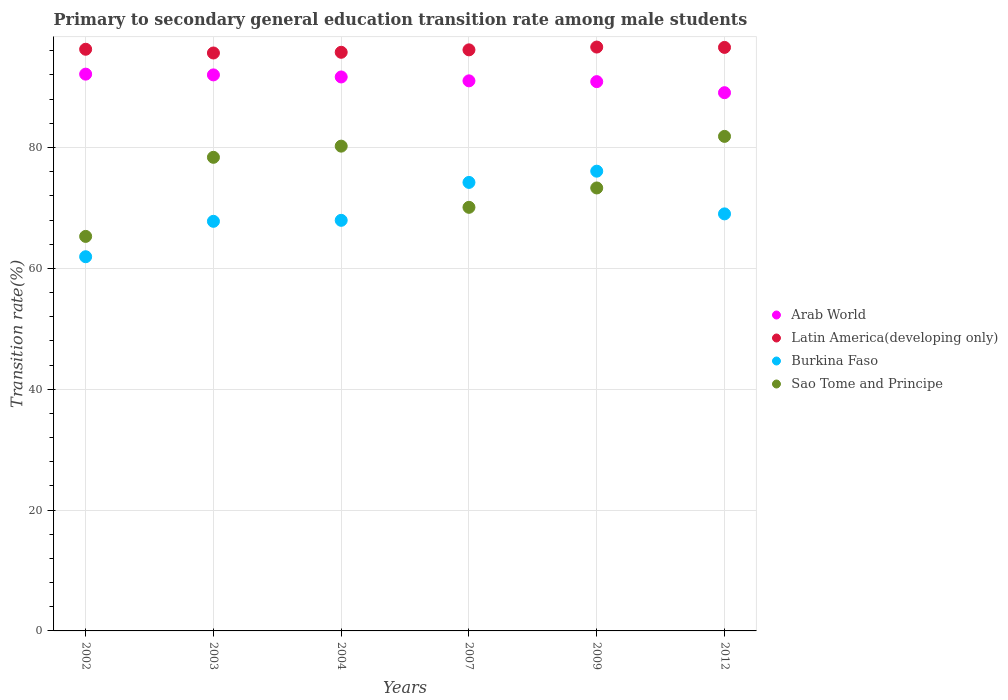How many different coloured dotlines are there?
Provide a succinct answer. 4. What is the transition rate in Burkina Faso in 2003?
Offer a terse response. 67.78. Across all years, what is the maximum transition rate in Sao Tome and Principe?
Offer a very short reply. 81.84. Across all years, what is the minimum transition rate in Arab World?
Your answer should be compact. 89.07. In which year was the transition rate in Arab World maximum?
Offer a terse response. 2002. What is the total transition rate in Arab World in the graph?
Your answer should be very brief. 546.83. What is the difference between the transition rate in Sao Tome and Principe in 2004 and that in 2012?
Offer a terse response. -1.62. What is the difference between the transition rate in Arab World in 2002 and the transition rate in Latin America(developing only) in 2009?
Provide a short and direct response. -4.48. What is the average transition rate in Sao Tome and Principe per year?
Provide a succinct answer. 74.86. In the year 2003, what is the difference between the transition rate in Latin America(developing only) and transition rate in Arab World?
Your answer should be very brief. 3.62. In how many years, is the transition rate in Burkina Faso greater than 84 %?
Provide a short and direct response. 0. What is the ratio of the transition rate in Latin America(developing only) in 2007 to that in 2009?
Ensure brevity in your answer.  1. Is the transition rate in Latin America(developing only) in 2009 less than that in 2012?
Offer a terse response. No. What is the difference between the highest and the second highest transition rate in Latin America(developing only)?
Provide a short and direct response. 0.06. What is the difference between the highest and the lowest transition rate in Latin America(developing only)?
Make the answer very short. 0.98. Does the graph contain grids?
Provide a short and direct response. Yes. Where does the legend appear in the graph?
Provide a succinct answer. Center right. How many legend labels are there?
Ensure brevity in your answer.  4. What is the title of the graph?
Give a very brief answer. Primary to secondary general education transition rate among male students. Does "Colombia" appear as one of the legend labels in the graph?
Provide a succinct answer. No. What is the label or title of the X-axis?
Provide a succinct answer. Years. What is the label or title of the Y-axis?
Provide a succinct answer. Transition rate(%). What is the Transition rate(%) of Arab World in 2002?
Provide a short and direct response. 92.14. What is the Transition rate(%) of Latin America(developing only) in 2002?
Ensure brevity in your answer.  96.26. What is the Transition rate(%) of Burkina Faso in 2002?
Ensure brevity in your answer.  61.93. What is the Transition rate(%) of Sao Tome and Principe in 2002?
Make the answer very short. 65.29. What is the Transition rate(%) of Arab World in 2003?
Provide a succinct answer. 92.02. What is the Transition rate(%) of Latin America(developing only) in 2003?
Offer a terse response. 95.64. What is the Transition rate(%) of Burkina Faso in 2003?
Provide a succinct answer. 67.78. What is the Transition rate(%) of Sao Tome and Principe in 2003?
Make the answer very short. 78.38. What is the Transition rate(%) of Arab World in 2004?
Provide a short and direct response. 91.67. What is the Transition rate(%) in Latin America(developing only) in 2004?
Make the answer very short. 95.76. What is the Transition rate(%) in Burkina Faso in 2004?
Provide a short and direct response. 67.95. What is the Transition rate(%) of Sao Tome and Principe in 2004?
Offer a very short reply. 80.23. What is the Transition rate(%) of Arab World in 2007?
Give a very brief answer. 91.03. What is the Transition rate(%) of Latin America(developing only) in 2007?
Provide a short and direct response. 96.16. What is the Transition rate(%) of Burkina Faso in 2007?
Make the answer very short. 74.22. What is the Transition rate(%) of Sao Tome and Principe in 2007?
Keep it short and to the point. 70.1. What is the Transition rate(%) in Arab World in 2009?
Give a very brief answer. 90.9. What is the Transition rate(%) in Latin America(developing only) in 2009?
Provide a short and direct response. 96.62. What is the Transition rate(%) of Burkina Faso in 2009?
Keep it short and to the point. 76.08. What is the Transition rate(%) in Sao Tome and Principe in 2009?
Keep it short and to the point. 73.3. What is the Transition rate(%) of Arab World in 2012?
Make the answer very short. 89.07. What is the Transition rate(%) in Latin America(developing only) in 2012?
Your answer should be compact. 96.56. What is the Transition rate(%) of Burkina Faso in 2012?
Give a very brief answer. 69.02. What is the Transition rate(%) in Sao Tome and Principe in 2012?
Make the answer very short. 81.84. Across all years, what is the maximum Transition rate(%) in Arab World?
Provide a short and direct response. 92.14. Across all years, what is the maximum Transition rate(%) of Latin America(developing only)?
Provide a succinct answer. 96.62. Across all years, what is the maximum Transition rate(%) in Burkina Faso?
Offer a terse response. 76.08. Across all years, what is the maximum Transition rate(%) of Sao Tome and Principe?
Your response must be concise. 81.84. Across all years, what is the minimum Transition rate(%) in Arab World?
Offer a terse response. 89.07. Across all years, what is the minimum Transition rate(%) of Latin America(developing only)?
Keep it short and to the point. 95.64. Across all years, what is the minimum Transition rate(%) in Burkina Faso?
Your answer should be compact. 61.93. Across all years, what is the minimum Transition rate(%) of Sao Tome and Principe?
Your answer should be very brief. 65.29. What is the total Transition rate(%) in Arab World in the graph?
Offer a very short reply. 546.83. What is the total Transition rate(%) of Latin America(developing only) in the graph?
Your response must be concise. 577.01. What is the total Transition rate(%) in Burkina Faso in the graph?
Keep it short and to the point. 416.98. What is the total Transition rate(%) in Sao Tome and Principe in the graph?
Offer a terse response. 449.14. What is the difference between the Transition rate(%) of Arab World in 2002 and that in 2003?
Your answer should be compact. 0.12. What is the difference between the Transition rate(%) in Latin America(developing only) in 2002 and that in 2003?
Keep it short and to the point. 0.62. What is the difference between the Transition rate(%) of Burkina Faso in 2002 and that in 2003?
Give a very brief answer. -5.86. What is the difference between the Transition rate(%) of Sao Tome and Principe in 2002 and that in 2003?
Keep it short and to the point. -13.09. What is the difference between the Transition rate(%) of Arab World in 2002 and that in 2004?
Provide a short and direct response. 0.47. What is the difference between the Transition rate(%) in Latin America(developing only) in 2002 and that in 2004?
Keep it short and to the point. 0.5. What is the difference between the Transition rate(%) of Burkina Faso in 2002 and that in 2004?
Ensure brevity in your answer.  -6.02. What is the difference between the Transition rate(%) in Sao Tome and Principe in 2002 and that in 2004?
Your answer should be compact. -14.94. What is the difference between the Transition rate(%) of Arab World in 2002 and that in 2007?
Your answer should be very brief. 1.11. What is the difference between the Transition rate(%) in Latin America(developing only) in 2002 and that in 2007?
Provide a succinct answer. 0.1. What is the difference between the Transition rate(%) in Burkina Faso in 2002 and that in 2007?
Offer a terse response. -12.3. What is the difference between the Transition rate(%) of Sao Tome and Principe in 2002 and that in 2007?
Ensure brevity in your answer.  -4.81. What is the difference between the Transition rate(%) in Arab World in 2002 and that in 2009?
Give a very brief answer. 1.24. What is the difference between the Transition rate(%) in Latin America(developing only) in 2002 and that in 2009?
Offer a very short reply. -0.36. What is the difference between the Transition rate(%) in Burkina Faso in 2002 and that in 2009?
Ensure brevity in your answer.  -14.16. What is the difference between the Transition rate(%) in Sao Tome and Principe in 2002 and that in 2009?
Your response must be concise. -8.02. What is the difference between the Transition rate(%) of Arab World in 2002 and that in 2012?
Ensure brevity in your answer.  3.07. What is the difference between the Transition rate(%) in Latin America(developing only) in 2002 and that in 2012?
Your answer should be compact. -0.31. What is the difference between the Transition rate(%) of Burkina Faso in 2002 and that in 2012?
Your answer should be compact. -7.09. What is the difference between the Transition rate(%) in Sao Tome and Principe in 2002 and that in 2012?
Your answer should be compact. -16.55. What is the difference between the Transition rate(%) of Arab World in 2003 and that in 2004?
Offer a terse response. 0.34. What is the difference between the Transition rate(%) of Latin America(developing only) in 2003 and that in 2004?
Your answer should be very brief. -0.12. What is the difference between the Transition rate(%) of Burkina Faso in 2003 and that in 2004?
Offer a terse response. -0.16. What is the difference between the Transition rate(%) in Sao Tome and Principe in 2003 and that in 2004?
Offer a terse response. -1.85. What is the difference between the Transition rate(%) of Arab World in 2003 and that in 2007?
Your answer should be compact. 0.99. What is the difference between the Transition rate(%) of Latin America(developing only) in 2003 and that in 2007?
Make the answer very short. -0.52. What is the difference between the Transition rate(%) of Burkina Faso in 2003 and that in 2007?
Offer a terse response. -6.44. What is the difference between the Transition rate(%) of Sao Tome and Principe in 2003 and that in 2007?
Your answer should be very brief. 8.28. What is the difference between the Transition rate(%) in Arab World in 2003 and that in 2009?
Provide a short and direct response. 1.12. What is the difference between the Transition rate(%) in Latin America(developing only) in 2003 and that in 2009?
Your response must be concise. -0.98. What is the difference between the Transition rate(%) in Burkina Faso in 2003 and that in 2009?
Your response must be concise. -8.3. What is the difference between the Transition rate(%) of Sao Tome and Principe in 2003 and that in 2009?
Keep it short and to the point. 5.07. What is the difference between the Transition rate(%) of Arab World in 2003 and that in 2012?
Your answer should be very brief. 2.95. What is the difference between the Transition rate(%) of Latin America(developing only) in 2003 and that in 2012?
Your answer should be very brief. -0.92. What is the difference between the Transition rate(%) of Burkina Faso in 2003 and that in 2012?
Give a very brief answer. -1.23. What is the difference between the Transition rate(%) in Sao Tome and Principe in 2003 and that in 2012?
Keep it short and to the point. -3.46. What is the difference between the Transition rate(%) of Arab World in 2004 and that in 2007?
Provide a short and direct response. 0.64. What is the difference between the Transition rate(%) in Latin America(developing only) in 2004 and that in 2007?
Give a very brief answer. -0.4. What is the difference between the Transition rate(%) of Burkina Faso in 2004 and that in 2007?
Provide a short and direct response. -6.27. What is the difference between the Transition rate(%) of Sao Tome and Principe in 2004 and that in 2007?
Keep it short and to the point. 10.13. What is the difference between the Transition rate(%) of Arab World in 2004 and that in 2009?
Give a very brief answer. 0.77. What is the difference between the Transition rate(%) of Latin America(developing only) in 2004 and that in 2009?
Offer a very short reply. -0.87. What is the difference between the Transition rate(%) of Burkina Faso in 2004 and that in 2009?
Provide a short and direct response. -8.13. What is the difference between the Transition rate(%) of Sao Tome and Principe in 2004 and that in 2009?
Make the answer very short. 6.92. What is the difference between the Transition rate(%) in Arab World in 2004 and that in 2012?
Offer a terse response. 2.6. What is the difference between the Transition rate(%) in Latin America(developing only) in 2004 and that in 2012?
Make the answer very short. -0.81. What is the difference between the Transition rate(%) of Burkina Faso in 2004 and that in 2012?
Ensure brevity in your answer.  -1.07. What is the difference between the Transition rate(%) of Sao Tome and Principe in 2004 and that in 2012?
Offer a very short reply. -1.62. What is the difference between the Transition rate(%) of Arab World in 2007 and that in 2009?
Make the answer very short. 0.13. What is the difference between the Transition rate(%) of Latin America(developing only) in 2007 and that in 2009?
Offer a terse response. -0.46. What is the difference between the Transition rate(%) in Burkina Faso in 2007 and that in 2009?
Your answer should be compact. -1.86. What is the difference between the Transition rate(%) in Sao Tome and Principe in 2007 and that in 2009?
Provide a succinct answer. -3.2. What is the difference between the Transition rate(%) in Arab World in 2007 and that in 2012?
Offer a very short reply. 1.96. What is the difference between the Transition rate(%) in Latin America(developing only) in 2007 and that in 2012?
Offer a very short reply. -0.4. What is the difference between the Transition rate(%) in Burkina Faso in 2007 and that in 2012?
Your answer should be very brief. 5.21. What is the difference between the Transition rate(%) in Sao Tome and Principe in 2007 and that in 2012?
Provide a short and direct response. -11.74. What is the difference between the Transition rate(%) in Arab World in 2009 and that in 2012?
Your response must be concise. 1.83. What is the difference between the Transition rate(%) in Latin America(developing only) in 2009 and that in 2012?
Offer a very short reply. 0.06. What is the difference between the Transition rate(%) of Burkina Faso in 2009 and that in 2012?
Your answer should be compact. 7.07. What is the difference between the Transition rate(%) in Sao Tome and Principe in 2009 and that in 2012?
Your answer should be compact. -8.54. What is the difference between the Transition rate(%) of Arab World in 2002 and the Transition rate(%) of Latin America(developing only) in 2003?
Your answer should be compact. -3.5. What is the difference between the Transition rate(%) of Arab World in 2002 and the Transition rate(%) of Burkina Faso in 2003?
Keep it short and to the point. 24.36. What is the difference between the Transition rate(%) of Arab World in 2002 and the Transition rate(%) of Sao Tome and Principe in 2003?
Your answer should be very brief. 13.76. What is the difference between the Transition rate(%) of Latin America(developing only) in 2002 and the Transition rate(%) of Burkina Faso in 2003?
Your response must be concise. 28.48. What is the difference between the Transition rate(%) in Latin America(developing only) in 2002 and the Transition rate(%) in Sao Tome and Principe in 2003?
Keep it short and to the point. 17.88. What is the difference between the Transition rate(%) in Burkina Faso in 2002 and the Transition rate(%) in Sao Tome and Principe in 2003?
Your answer should be very brief. -16.45. What is the difference between the Transition rate(%) in Arab World in 2002 and the Transition rate(%) in Latin America(developing only) in 2004?
Offer a very short reply. -3.62. What is the difference between the Transition rate(%) of Arab World in 2002 and the Transition rate(%) of Burkina Faso in 2004?
Your answer should be compact. 24.19. What is the difference between the Transition rate(%) in Arab World in 2002 and the Transition rate(%) in Sao Tome and Principe in 2004?
Ensure brevity in your answer.  11.91. What is the difference between the Transition rate(%) of Latin America(developing only) in 2002 and the Transition rate(%) of Burkina Faso in 2004?
Offer a very short reply. 28.31. What is the difference between the Transition rate(%) of Latin America(developing only) in 2002 and the Transition rate(%) of Sao Tome and Principe in 2004?
Your answer should be very brief. 16.03. What is the difference between the Transition rate(%) in Burkina Faso in 2002 and the Transition rate(%) in Sao Tome and Principe in 2004?
Keep it short and to the point. -18.3. What is the difference between the Transition rate(%) of Arab World in 2002 and the Transition rate(%) of Latin America(developing only) in 2007?
Keep it short and to the point. -4.02. What is the difference between the Transition rate(%) in Arab World in 2002 and the Transition rate(%) in Burkina Faso in 2007?
Offer a very short reply. 17.92. What is the difference between the Transition rate(%) in Arab World in 2002 and the Transition rate(%) in Sao Tome and Principe in 2007?
Your answer should be compact. 22.04. What is the difference between the Transition rate(%) in Latin America(developing only) in 2002 and the Transition rate(%) in Burkina Faso in 2007?
Your response must be concise. 22.04. What is the difference between the Transition rate(%) in Latin America(developing only) in 2002 and the Transition rate(%) in Sao Tome and Principe in 2007?
Ensure brevity in your answer.  26.16. What is the difference between the Transition rate(%) of Burkina Faso in 2002 and the Transition rate(%) of Sao Tome and Principe in 2007?
Offer a very short reply. -8.17. What is the difference between the Transition rate(%) in Arab World in 2002 and the Transition rate(%) in Latin America(developing only) in 2009?
Give a very brief answer. -4.48. What is the difference between the Transition rate(%) in Arab World in 2002 and the Transition rate(%) in Burkina Faso in 2009?
Offer a terse response. 16.06. What is the difference between the Transition rate(%) of Arab World in 2002 and the Transition rate(%) of Sao Tome and Principe in 2009?
Provide a short and direct response. 18.83. What is the difference between the Transition rate(%) of Latin America(developing only) in 2002 and the Transition rate(%) of Burkina Faso in 2009?
Provide a short and direct response. 20.18. What is the difference between the Transition rate(%) in Latin America(developing only) in 2002 and the Transition rate(%) in Sao Tome and Principe in 2009?
Give a very brief answer. 22.95. What is the difference between the Transition rate(%) in Burkina Faso in 2002 and the Transition rate(%) in Sao Tome and Principe in 2009?
Provide a succinct answer. -11.38. What is the difference between the Transition rate(%) of Arab World in 2002 and the Transition rate(%) of Latin America(developing only) in 2012?
Provide a short and direct response. -4.43. What is the difference between the Transition rate(%) of Arab World in 2002 and the Transition rate(%) of Burkina Faso in 2012?
Make the answer very short. 23.12. What is the difference between the Transition rate(%) in Arab World in 2002 and the Transition rate(%) in Sao Tome and Principe in 2012?
Your response must be concise. 10.3. What is the difference between the Transition rate(%) in Latin America(developing only) in 2002 and the Transition rate(%) in Burkina Faso in 2012?
Your response must be concise. 27.24. What is the difference between the Transition rate(%) in Latin America(developing only) in 2002 and the Transition rate(%) in Sao Tome and Principe in 2012?
Give a very brief answer. 14.42. What is the difference between the Transition rate(%) in Burkina Faso in 2002 and the Transition rate(%) in Sao Tome and Principe in 2012?
Provide a short and direct response. -19.91. What is the difference between the Transition rate(%) of Arab World in 2003 and the Transition rate(%) of Latin America(developing only) in 2004?
Make the answer very short. -3.74. What is the difference between the Transition rate(%) of Arab World in 2003 and the Transition rate(%) of Burkina Faso in 2004?
Offer a terse response. 24.07. What is the difference between the Transition rate(%) of Arab World in 2003 and the Transition rate(%) of Sao Tome and Principe in 2004?
Make the answer very short. 11.79. What is the difference between the Transition rate(%) in Latin America(developing only) in 2003 and the Transition rate(%) in Burkina Faso in 2004?
Your response must be concise. 27.69. What is the difference between the Transition rate(%) of Latin America(developing only) in 2003 and the Transition rate(%) of Sao Tome and Principe in 2004?
Ensure brevity in your answer.  15.42. What is the difference between the Transition rate(%) of Burkina Faso in 2003 and the Transition rate(%) of Sao Tome and Principe in 2004?
Give a very brief answer. -12.44. What is the difference between the Transition rate(%) in Arab World in 2003 and the Transition rate(%) in Latin America(developing only) in 2007?
Your answer should be very brief. -4.14. What is the difference between the Transition rate(%) in Arab World in 2003 and the Transition rate(%) in Burkina Faso in 2007?
Offer a very short reply. 17.79. What is the difference between the Transition rate(%) in Arab World in 2003 and the Transition rate(%) in Sao Tome and Principe in 2007?
Provide a short and direct response. 21.92. What is the difference between the Transition rate(%) in Latin America(developing only) in 2003 and the Transition rate(%) in Burkina Faso in 2007?
Keep it short and to the point. 21.42. What is the difference between the Transition rate(%) in Latin America(developing only) in 2003 and the Transition rate(%) in Sao Tome and Principe in 2007?
Give a very brief answer. 25.54. What is the difference between the Transition rate(%) of Burkina Faso in 2003 and the Transition rate(%) of Sao Tome and Principe in 2007?
Offer a very short reply. -2.32. What is the difference between the Transition rate(%) in Arab World in 2003 and the Transition rate(%) in Latin America(developing only) in 2009?
Ensure brevity in your answer.  -4.61. What is the difference between the Transition rate(%) of Arab World in 2003 and the Transition rate(%) of Burkina Faso in 2009?
Keep it short and to the point. 15.93. What is the difference between the Transition rate(%) of Arab World in 2003 and the Transition rate(%) of Sao Tome and Principe in 2009?
Provide a succinct answer. 18.71. What is the difference between the Transition rate(%) of Latin America(developing only) in 2003 and the Transition rate(%) of Burkina Faso in 2009?
Keep it short and to the point. 19.56. What is the difference between the Transition rate(%) of Latin America(developing only) in 2003 and the Transition rate(%) of Sao Tome and Principe in 2009?
Your answer should be very brief. 22.34. What is the difference between the Transition rate(%) of Burkina Faso in 2003 and the Transition rate(%) of Sao Tome and Principe in 2009?
Offer a terse response. -5.52. What is the difference between the Transition rate(%) of Arab World in 2003 and the Transition rate(%) of Latin America(developing only) in 2012?
Give a very brief answer. -4.55. What is the difference between the Transition rate(%) in Arab World in 2003 and the Transition rate(%) in Burkina Faso in 2012?
Make the answer very short. 23. What is the difference between the Transition rate(%) of Arab World in 2003 and the Transition rate(%) of Sao Tome and Principe in 2012?
Your answer should be very brief. 10.18. What is the difference between the Transition rate(%) of Latin America(developing only) in 2003 and the Transition rate(%) of Burkina Faso in 2012?
Make the answer very short. 26.63. What is the difference between the Transition rate(%) in Latin America(developing only) in 2003 and the Transition rate(%) in Sao Tome and Principe in 2012?
Make the answer very short. 13.8. What is the difference between the Transition rate(%) of Burkina Faso in 2003 and the Transition rate(%) of Sao Tome and Principe in 2012?
Your answer should be very brief. -14.06. What is the difference between the Transition rate(%) of Arab World in 2004 and the Transition rate(%) of Latin America(developing only) in 2007?
Make the answer very short. -4.49. What is the difference between the Transition rate(%) of Arab World in 2004 and the Transition rate(%) of Burkina Faso in 2007?
Ensure brevity in your answer.  17.45. What is the difference between the Transition rate(%) of Arab World in 2004 and the Transition rate(%) of Sao Tome and Principe in 2007?
Offer a very short reply. 21.57. What is the difference between the Transition rate(%) of Latin America(developing only) in 2004 and the Transition rate(%) of Burkina Faso in 2007?
Offer a terse response. 21.53. What is the difference between the Transition rate(%) of Latin America(developing only) in 2004 and the Transition rate(%) of Sao Tome and Principe in 2007?
Provide a succinct answer. 25.66. What is the difference between the Transition rate(%) in Burkina Faso in 2004 and the Transition rate(%) in Sao Tome and Principe in 2007?
Your response must be concise. -2.15. What is the difference between the Transition rate(%) of Arab World in 2004 and the Transition rate(%) of Latin America(developing only) in 2009?
Your response must be concise. -4.95. What is the difference between the Transition rate(%) in Arab World in 2004 and the Transition rate(%) in Burkina Faso in 2009?
Offer a terse response. 15.59. What is the difference between the Transition rate(%) in Arab World in 2004 and the Transition rate(%) in Sao Tome and Principe in 2009?
Provide a succinct answer. 18.37. What is the difference between the Transition rate(%) in Latin America(developing only) in 2004 and the Transition rate(%) in Burkina Faso in 2009?
Make the answer very short. 19.67. What is the difference between the Transition rate(%) of Latin America(developing only) in 2004 and the Transition rate(%) of Sao Tome and Principe in 2009?
Make the answer very short. 22.45. What is the difference between the Transition rate(%) of Burkina Faso in 2004 and the Transition rate(%) of Sao Tome and Principe in 2009?
Provide a short and direct response. -5.36. What is the difference between the Transition rate(%) of Arab World in 2004 and the Transition rate(%) of Latin America(developing only) in 2012?
Provide a succinct answer. -4.89. What is the difference between the Transition rate(%) of Arab World in 2004 and the Transition rate(%) of Burkina Faso in 2012?
Ensure brevity in your answer.  22.66. What is the difference between the Transition rate(%) in Arab World in 2004 and the Transition rate(%) in Sao Tome and Principe in 2012?
Provide a succinct answer. 9.83. What is the difference between the Transition rate(%) of Latin America(developing only) in 2004 and the Transition rate(%) of Burkina Faso in 2012?
Give a very brief answer. 26.74. What is the difference between the Transition rate(%) in Latin America(developing only) in 2004 and the Transition rate(%) in Sao Tome and Principe in 2012?
Provide a short and direct response. 13.92. What is the difference between the Transition rate(%) of Burkina Faso in 2004 and the Transition rate(%) of Sao Tome and Principe in 2012?
Your answer should be compact. -13.89. What is the difference between the Transition rate(%) in Arab World in 2007 and the Transition rate(%) in Latin America(developing only) in 2009?
Keep it short and to the point. -5.59. What is the difference between the Transition rate(%) of Arab World in 2007 and the Transition rate(%) of Burkina Faso in 2009?
Offer a very short reply. 14.95. What is the difference between the Transition rate(%) of Arab World in 2007 and the Transition rate(%) of Sao Tome and Principe in 2009?
Offer a terse response. 17.73. What is the difference between the Transition rate(%) of Latin America(developing only) in 2007 and the Transition rate(%) of Burkina Faso in 2009?
Your answer should be compact. 20.08. What is the difference between the Transition rate(%) of Latin America(developing only) in 2007 and the Transition rate(%) of Sao Tome and Principe in 2009?
Offer a very short reply. 22.86. What is the difference between the Transition rate(%) of Burkina Faso in 2007 and the Transition rate(%) of Sao Tome and Principe in 2009?
Provide a succinct answer. 0.92. What is the difference between the Transition rate(%) of Arab World in 2007 and the Transition rate(%) of Latin America(developing only) in 2012?
Offer a very short reply. -5.53. What is the difference between the Transition rate(%) of Arab World in 2007 and the Transition rate(%) of Burkina Faso in 2012?
Offer a very short reply. 22.02. What is the difference between the Transition rate(%) in Arab World in 2007 and the Transition rate(%) in Sao Tome and Principe in 2012?
Your answer should be compact. 9.19. What is the difference between the Transition rate(%) in Latin America(developing only) in 2007 and the Transition rate(%) in Burkina Faso in 2012?
Keep it short and to the point. 27.14. What is the difference between the Transition rate(%) of Latin America(developing only) in 2007 and the Transition rate(%) of Sao Tome and Principe in 2012?
Provide a short and direct response. 14.32. What is the difference between the Transition rate(%) of Burkina Faso in 2007 and the Transition rate(%) of Sao Tome and Principe in 2012?
Keep it short and to the point. -7.62. What is the difference between the Transition rate(%) of Arab World in 2009 and the Transition rate(%) of Latin America(developing only) in 2012?
Make the answer very short. -5.66. What is the difference between the Transition rate(%) of Arab World in 2009 and the Transition rate(%) of Burkina Faso in 2012?
Give a very brief answer. 21.89. What is the difference between the Transition rate(%) of Arab World in 2009 and the Transition rate(%) of Sao Tome and Principe in 2012?
Ensure brevity in your answer.  9.06. What is the difference between the Transition rate(%) in Latin America(developing only) in 2009 and the Transition rate(%) in Burkina Faso in 2012?
Keep it short and to the point. 27.61. What is the difference between the Transition rate(%) in Latin America(developing only) in 2009 and the Transition rate(%) in Sao Tome and Principe in 2012?
Give a very brief answer. 14.78. What is the difference between the Transition rate(%) in Burkina Faso in 2009 and the Transition rate(%) in Sao Tome and Principe in 2012?
Make the answer very short. -5.76. What is the average Transition rate(%) of Arab World per year?
Offer a terse response. 91.14. What is the average Transition rate(%) in Latin America(developing only) per year?
Provide a short and direct response. 96.17. What is the average Transition rate(%) of Burkina Faso per year?
Offer a terse response. 69.5. What is the average Transition rate(%) of Sao Tome and Principe per year?
Provide a short and direct response. 74.86. In the year 2002, what is the difference between the Transition rate(%) of Arab World and Transition rate(%) of Latin America(developing only)?
Your response must be concise. -4.12. In the year 2002, what is the difference between the Transition rate(%) in Arab World and Transition rate(%) in Burkina Faso?
Your response must be concise. 30.21. In the year 2002, what is the difference between the Transition rate(%) in Arab World and Transition rate(%) in Sao Tome and Principe?
Offer a terse response. 26.85. In the year 2002, what is the difference between the Transition rate(%) in Latin America(developing only) and Transition rate(%) in Burkina Faso?
Offer a very short reply. 34.33. In the year 2002, what is the difference between the Transition rate(%) in Latin America(developing only) and Transition rate(%) in Sao Tome and Principe?
Your response must be concise. 30.97. In the year 2002, what is the difference between the Transition rate(%) of Burkina Faso and Transition rate(%) of Sao Tome and Principe?
Your response must be concise. -3.36. In the year 2003, what is the difference between the Transition rate(%) in Arab World and Transition rate(%) in Latin America(developing only)?
Make the answer very short. -3.62. In the year 2003, what is the difference between the Transition rate(%) in Arab World and Transition rate(%) in Burkina Faso?
Give a very brief answer. 24.23. In the year 2003, what is the difference between the Transition rate(%) of Arab World and Transition rate(%) of Sao Tome and Principe?
Provide a succinct answer. 13.64. In the year 2003, what is the difference between the Transition rate(%) in Latin America(developing only) and Transition rate(%) in Burkina Faso?
Provide a succinct answer. 27.86. In the year 2003, what is the difference between the Transition rate(%) in Latin America(developing only) and Transition rate(%) in Sao Tome and Principe?
Offer a very short reply. 17.26. In the year 2003, what is the difference between the Transition rate(%) in Burkina Faso and Transition rate(%) in Sao Tome and Principe?
Keep it short and to the point. -10.59. In the year 2004, what is the difference between the Transition rate(%) of Arab World and Transition rate(%) of Latin America(developing only)?
Provide a short and direct response. -4.08. In the year 2004, what is the difference between the Transition rate(%) in Arab World and Transition rate(%) in Burkina Faso?
Provide a short and direct response. 23.73. In the year 2004, what is the difference between the Transition rate(%) of Arab World and Transition rate(%) of Sao Tome and Principe?
Your answer should be compact. 11.45. In the year 2004, what is the difference between the Transition rate(%) of Latin America(developing only) and Transition rate(%) of Burkina Faso?
Your answer should be very brief. 27.81. In the year 2004, what is the difference between the Transition rate(%) of Latin America(developing only) and Transition rate(%) of Sao Tome and Principe?
Your answer should be compact. 15.53. In the year 2004, what is the difference between the Transition rate(%) in Burkina Faso and Transition rate(%) in Sao Tome and Principe?
Keep it short and to the point. -12.28. In the year 2007, what is the difference between the Transition rate(%) of Arab World and Transition rate(%) of Latin America(developing only)?
Your answer should be compact. -5.13. In the year 2007, what is the difference between the Transition rate(%) in Arab World and Transition rate(%) in Burkina Faso?
Give a very brief answer. 16.81. In the year 2007, what is the difference between the Transition rate(%) in Arab World and Transition rate(%) in Sao Tome and Principe?
Provide a short and direct response. 20.93. In the year 2007, what is the difference between the Transition rate(%) of Latin America(developing only) and Transition rate(%) of Burkina Faso?
Your answer should be compact. 21.94. In the year 2007, what is the difference between the Transition rate(%) of Latin America(developing only) and Transition rate(%) of Sao Tome and Principe?
Your response must be concise. 26.06. In the year 2007, what is the difference between the Transition rate(%) in Burkina Faso and Transition rate(%) in Sao Tome and Principe?
Your response must be concise. 4.12. In the year 2009, what is the difference between the Transition rate(%) in Arab World and Transition rate(%) in Latin America(developing only)?
Keep it short and to the point. -5.72. In the year 2009, what is the difference between the Transition rate(%) in Arab World and Transition rate(%) in Burkina Faso?
Ensure brevity in your answer.  14.82. In the year 2009, what is the difference between the Transition rate(%) of Arab World and Transition rate(%) of Sao Tome and Principe?
Offer a terse response. 17.6. In the year 2009, what is the difference between the Transition rate(%) of Latin America(developing only) and Transition rate(%) of Burkina Faso?
Provide a succinct answer. 20.54. In the year 2009, what is the difference between the Transition rate(%) in Latin America(developing only) and Transition rate(%) in Sao Tome and Principe?
Make the answer very short. 23.32. In the year 2009, what is the difference between the Transition rate(%) of Burkina Faso and Transition rate(%) of Sao Tome and Principe?
Provide a short and direct response. 2.78. In the year 2012, what is the difference between the Transition rate(%) in Arab World and Transition rate(%) in Latin America(developing only)?
Ensure brevity in your answer.  -7.49. In the year 2012, what is the difference between the Transition rate(%) of Arab World and Transition rate(%) of Burkina Faso?
Your response must be concise. 20.05. In the year 2012, what is the difference between the Transition rate(%) of Arab World and Transition rate(%) of Sao Tome and Principe?
Give a very brief answer. 7.23. In the year 2012, what is the difference between the Transition rate(%) of Latin America(developing only) and Transition rate(%) of Burkina Faso?
Your response must be concise. 27.55. In the year 2012, what is the difference between the Transition rate(%) of Latin America(developing only) and Transition rate(%) of Sao Tome and Principe?
Your response must be concise. 14.72. In the year 2012, what is the difference between the Transition rate(%) of Burkina Faso and Transition rate(%) of Sao Tome and Principe?
Offer a very short reply. -12.82. What is the ratio of the Transition rate(%) of Arab World in 2002 to that in 2003?
Provide a succinct answer. 1. What is the ratio of the Transition rate(%) of Burkina Faso in 2002 to that in 2003?
Your answer should be very brief. 0.91. What is the ratio of the Transition rate(%) in Sao Tome and Principe in 2002 to that in 2003?
Ensure brevity in your answer.  0.83. What is the ratio of the Transition rate(%) of Arab World in 2002 to that in 2004?
Give a very brief answer. 1.01. What is the ratio of the Transition rate(%) of Latin America(developing only) in 2002 to that in 2004?
Your answer should be compact. 1.01. What is the ratio of the Transition rate(%) in Burkina Faso in 2002 to that in 2004?
Provide a short and direct response. 0.91. What is the ratio of the Transition rate(%) of Sao Tome and Principe in 2002 to that in 2004?
Offer a terse response. 0.81. What is the ratio of the Transition rate(%) in Arab World in 2002 to that in 2007?
Offer a terse response. 1.01. What is the ratio of the Transition rate(%) in Latin America(developing only) in 2002 to that in 2007?
Provide a succinct answer. 1. What is the ratio of the Transition rate(%) of Burkina Faso in 2002 to that in 2007?
Offer a terse response. 0.83. What is the ratio of the Transition rate(%) of Sao Tome and Principe in 2002 to that in 2007?
Your response must be concise. 0.93. What is the ratio of the Transition rate(%) in Arab World in 2002 to that in 2009?
Make the answer very short. 1.01. What is the ratio of the Transition rate(%) in Latin America(developing only) in 2002 to that in 2009?
Offer a very short reply. 1. What is the ratio of the Transition rate(%) in Burkina Faso in 2002 to that in 2009?
Provide a short and direct response. 0.81. What is the ratio of the Transition rate(%) of Sao Tome and Principe in 2002 to that in 2009?
Your answer should be very brief. 0.89. What is the ratio of the Transition rate(%) in Arab World in 2002 to that in 2012?
Keep it short and to the point. 1.03. What is the ratio of the Transition rate(%) in Latin America(developing only) in 2002 to that in 2012?
Ensure brevity in your answer.  1. What is the ratio of the Transition rate(%) of Burkina Faso in 2002 to that in 2012?
Your answer should be compact. 0.9. What is the ratio of the Transition rate(%) of Sao Tome and Principe in 2002 to that in 2012?
Your answer should be very brief. 0.8. What is the ratio of the Transition rate(%) of Arab World in 2003 to that in 2004?
Offer a terse response. 1. What is the ratio of the Transition rate(%) in Burkina Faso in 2003 to that in 2004?
Give a very brief answer. 1. What is the ratio of the Transition rate(%) of Arab World in 2003 to that in 2007?
Give a very brief answer. 1.01. What is the ratio of the Transition rate(%) of Latin America(developing only) in 2003 to that in 2007?
Your answer should be compact. 0.99. What is the ratio of the Transition rate(%) of Burkina Faso in 2003 to that in 2007?
Ensure brevity in your answer.  0.91. What is the ratio of the Transition rate(%) in Sao Tome and Principe in 2003 to that in 2007?
Give a very brief answer. 1.12. What is the ratio of the Transition rate(%) in Arab World in 2003 to that in 2009?
Provide a short and direct response. 1.01. What is the ratio of the Transition rate(%) in Latin America(developing only) in 2003 to that in 2009?
Keep it short and to the point. 0.99. What is the ratio of the Transition rate(%) of Burkina Faso in 2003 to that in 2009?
Make the answer very short. 0.89. What is the ratio of the Transition rate(%) of Sao Tome and Principe in 2003 to that in 2009?
Your answer should be compact. 1.07. What is the ratio of the Transition rate(%) of Arab World in 2003 to that in 2012?
Make the answer very short. 1.03. What is the ratio of the Transition rate(%) in Latin America(developing only) in 2003 to that in 2012?
Provide a short and direct response. 0.99. What is the ratio of the Transition rate(%) in Burkina Faso in 2003 to that in 2012?
Offer a very short reply. 0.98. What is the ratio of the Transition rate(%) of Sao Tome and Principe in 2003 to that in 2012?
Provide a succinct answer. 0.96. What is the ratio of the Transition rate(%) of Arab World in 2004 to that in 2007?
Your response must be concise. 1.01. What is the ratio of the Transition rate(%) of Latin America(developing only) in 2004 to that in 2007?
Offer a very short reply. 1. What is the ratio of the Transition rate(%) of Burkina Faso in 2004 to that in 2007?
Provide a succinct answer. 0.92. What is the ratio of the Transition rate(%) of Sao Tome and Principe in 2004 to that in 2007?
Offer a very short reply. 1.14. What is the ratio of the Transition rate(%) in Arab World in 2004 to that in 2009?
Ensure brevity in your answer.  1.01. What is the ratio of the Transition rate(%) of Latin America(developing only) in 2004 to that in 2009?
Your answer should be compact. 0.99. What is the ratio of the Transition rate(%) of Burkina Faso in 2004 to that in 2009?
Your answer should be compact. 0.89. What is the ratio of the Transition rate(%) of Sao Tome and Principe in 2004 to that in 2009?
Provide a short and direct response. 1.09. What is the ratio of the Transition rate(%) in Arab World in 2004 to that in 2012?
Offer a very short reply. 1.03. What is the ratio of the Transition rate(%) of Latin America(developing only) in 2004 to that in 2012?
Your response must be concise. 0.99. What is the ratio of the Transition rate(%) of Burkina Faso in 2004 to that in 2012?
Provide a short and direct response. 0.98. What is the ratio of the Transition rate(%) of Sao Tome and Principe in 2004 to that in 2012?
Provide a short and direct response. 0.98. What is the ratio of the Transition rate(%) of Burkina Faso in 2007 to that in 2009?
Keep it short and to the point. 0.98. What is the ratio of the Transition rate(%) of Sao Tome and Principe in 2007 to that in 2009?
Offer a terse response. 0.96. What is the ratio of the Transition rate(%) in Arab World in 2007 to that in 2012?
Offer a very short reply. 1.02. What is the ratio of the Transition rate(%) in Latin America(developing only) in 2007 to that in 2012?
Your answer should be compact. 1. What is the ratio of the Transition rate(%) in Burkina Faso in 2007 to that in 2012?
Your response must be concise. 1.08. What is the ratio of the Transition rate(%) of Sao Tome and Principe in 2007 to that in 2012?
Ensure brevity in your answer.  0.86. What is the ratio of the Transition rate(%) in Arab World in 2009 to that in 2012?
Your answer should be very brief. 1.02. What is the ratio of the Transition rate(%) of Burkina Faso in 2009 to that in 2012?
Keep it short and to the point. 1.1. What is the ratio of the Transition rate(%) of Sao Tome and Principe in 2009 to that in 2012?
Keep it short and to the point. 0.9. What is the difference between the highest and the second highest Transition rate(%) in Arab World?
Your answer should be very brief. 0.12. What is the difference between the highest and the second highest Transition rate(%) in Latin America(developing only)?
Offer a terse response. 0.06. What is the difference between the highest and the second highest Transition rate(%) of Burkina Faso?
Keep it short and to the point. 1.86. What is the difference between the highest and the second highest Transition rate(%) of Sao Tome and Principe?
Offer a very short reply. 1.62. What is the difference between the highest and the lowest Transition rate(%) of Arab World?
Provide a succinct answer. 3.07. What is the difference between the highest and the lowest Transition rate(%) in Latin America(developing only)?
Make the answer very short. 0.98. What is the difference between the highest and the lowest Transition rate(%) in Burkina Faso?
Give a very brief answer. 14.16. What is the difference between the highest and the lowest Transition rate(%) in Sao Tome and Principe?
Give a very brief answer. 16.55. 